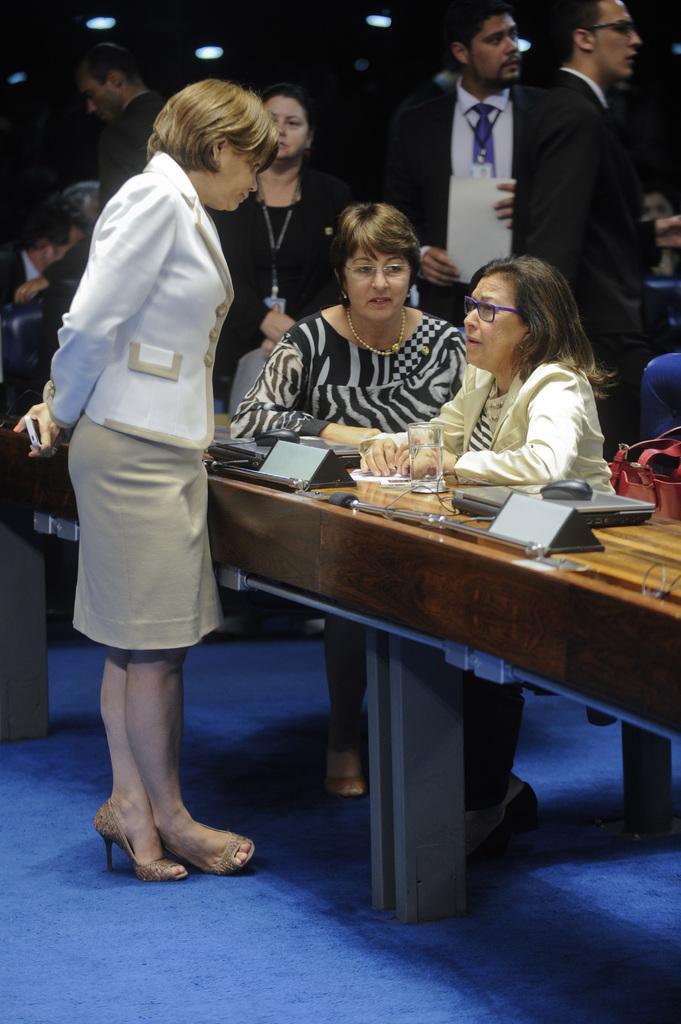How would you summarize this image in a sentence or two? In this picture, there are two woman sitting in the chair in front of a table on which name plates, laptops and mouses were there. There is another woman standing in front of the table. In the background there are some people standing and sitting in the chairs. 